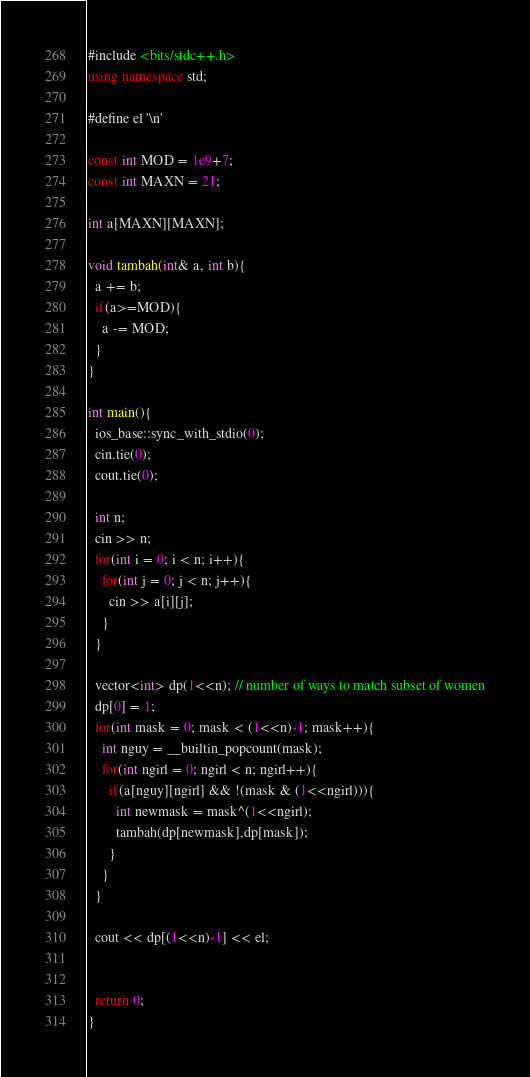Convert code to text. <code><loc_0><loc_0><loc_500><loc_500><_C++_>#include <bits/stdc++.h>
using namespace std;

#define el '\n'

const int MOD = 1e9+7;
const int MAXN = 21;

int a[MAXN][MAXN];

void tambah(int& a, int b){
  a += b;
  if(a>=MOD){
    a -= MOD;
  }
}

int main(){
  ios_base::sync_with_stdio(0);
  cin.tie(0);
  cout.tie(0);

  int n;
  cin >> n;
  for(int i = 0; i < n; i++){
    for(int j = 0; j < n; j++){
      cin >> a[i][j];
    }
  }

  vector<int> dp(1<<n); // number of ways to match subset of women
  dp[0] = 1;
  for(int mask = 0; mask < (1<<n)-1; mask++){
    int nguy = __builtin_popcount(mask);
    for(int ngirl = 0; ngirl < n; ngirl++){
      if(a[nguy][ngirl] && !(mask & (1<<ngirl))){
        int newmask = mask^(1<<ngirl);
        tambah(dp[newmask],dp[mask]);
      }
    }
  }

  cout << dp[(1<<n)-1] << el;

  
  return 0;
}</code> 